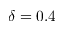Convert formula to latex. <formula><loc_0><loc_0><loc_500><loc_500>\delta = 0 . 4</formula> 